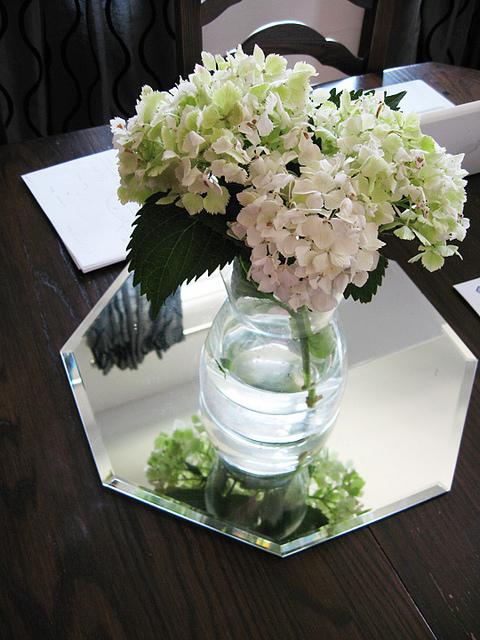What are flowers in?
Concise answer only. Vase. What is seen in the reflection?
Write a very short answer. Flowers. What color are the flowers?
Give a very brief answer. White. 